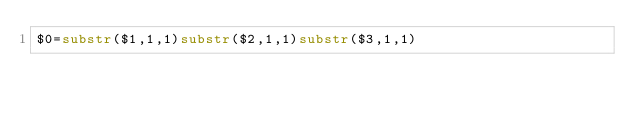<code> <loc_0><loc_0><loc_500><loc_500><_Awk_>$0=substr($1,1,1)substr($2,1,1)substr($3,1,1)</code> 